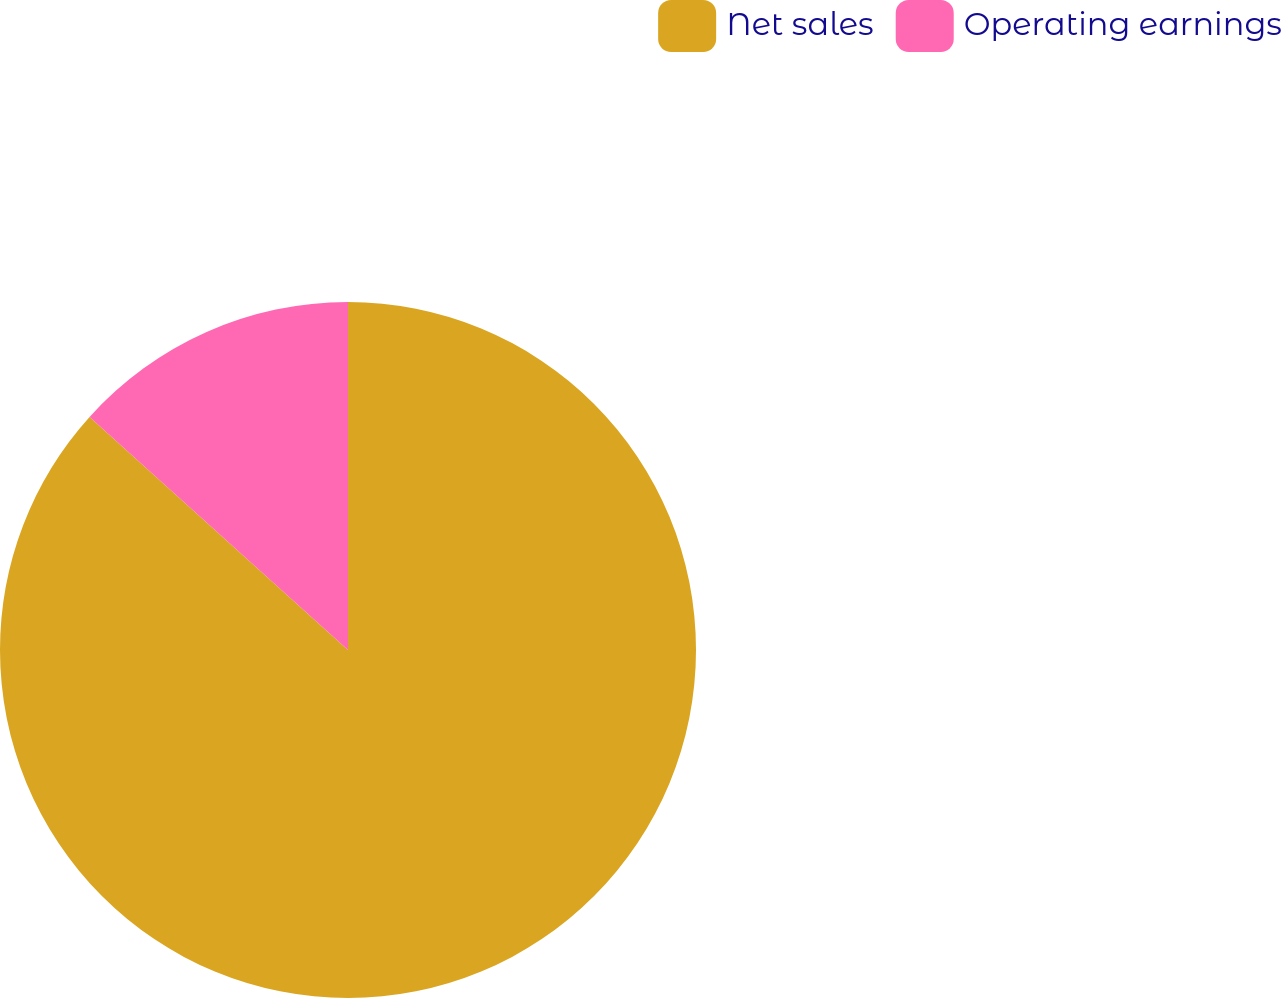Convert chart to OTSL. <chart><loc_0><loc_0><loc_500><loc_500><pie_chart><fcel>Net sales<fcel>Operating earnings<nl><fcel>86.68%<fcel>13.32%<nl></chart> 